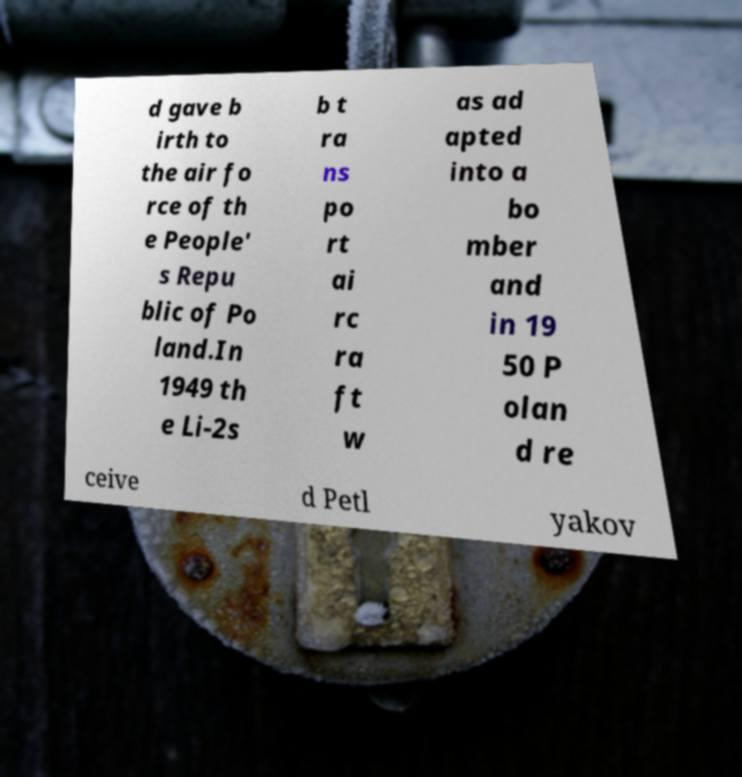Please identify and transcribe the text found in this image. d gave b irth to the air fo rce of th e People' s Repu blic of Po land.In 1949 th e Li-2s b t ra ns po rt ai rc ra ft w as ad apted into a bo mber and in 19 50 P olan d re ceive d Petl yakov 